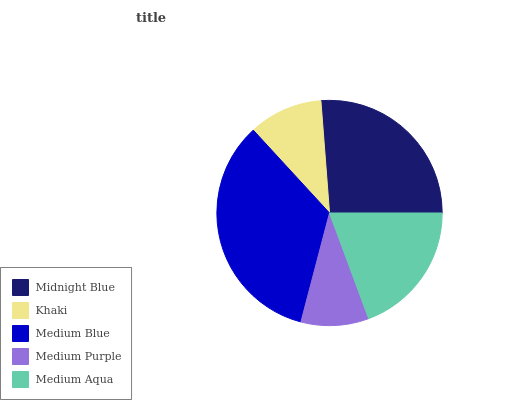Is Medium Purple the minimum?
Answer yes or no. Yes. Is Medium Blue the maximum?
Answer yes or no. Yes. Is Khaki the minimum?
Answer yes or no. No. Is Khaki the maximum?
Answer yes or no. No. Is Midnight Blue greater than Khaki?
Answer yes or no. Yes. Is Khaki less than Midnight Blue?
Answer yes or no. Yes. Is Khaki greater than Midnight Blue?
Answer yes or no. No. Is Midnight Blue less than Khaki?
Answer yes or no. No. Is Medium Aqua the high median?
Answer yes or no. Yes. Is Medium Aqua the low median?
Answer yes or no. Yes. Is Medium Blue the high median?
Answer yes or no. No. Is Midnight Blue the low median?
Answer yes or no. No. 